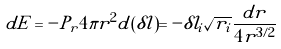<formula> <loc_0><loc_0><loc_500><loc_500>d E = - P _ { r } 4 \pi r ^ { 2 } d ( \delta l ) = - \delta l _ { i } \sqrt { r _ { i } } \frac { d r } { 4 r ^ { 3 / 2 } }</formula> 